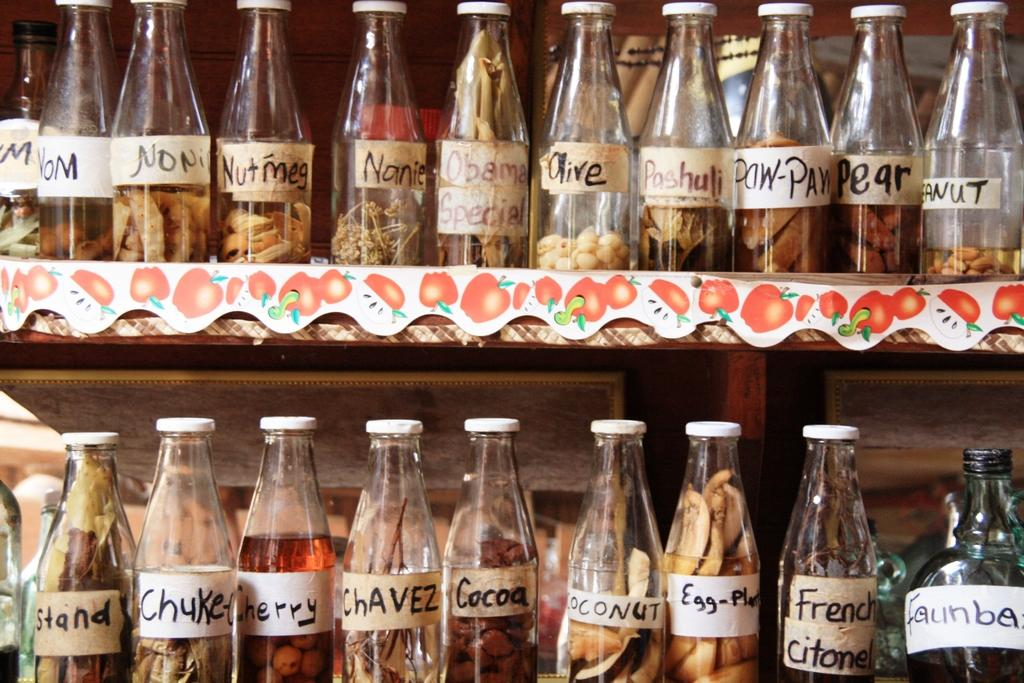What objects are present in the image? There are bottles in the image. How are the bottles arranged? The bottles are in racks. What additional feature can be seen on each bottle? There are stickers on each of the bottles. What type of frog can be seen in the image? There is no frog present in the image; it features bottles in racks with stickers on them. What is the condition of the earthquake in the image? There is no earthquake present in the image; it features bottles in racks with stickers on them. 